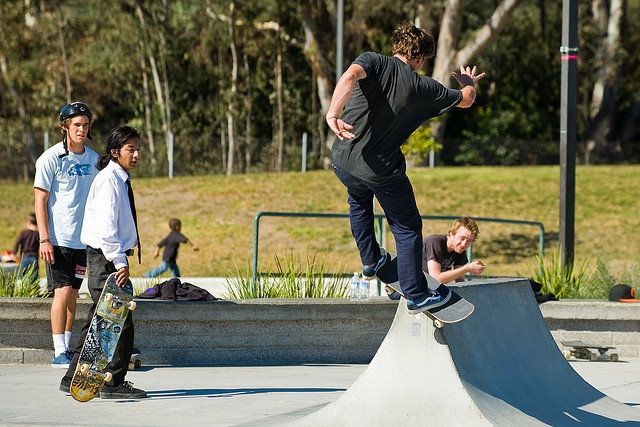Describe the objects in this image and their specific colors. I can see people in darkgreen, black, gray, navy, and darkblue tones, people in darkgreen, white, black, and gray tones, people in darkgreen, black, white, gray, and darkgray tones, skateboard in darkgreen, black, gray, darkgray, and olive tones, and people in darkgreen, black, brown, tan, and gray tones in this image. 